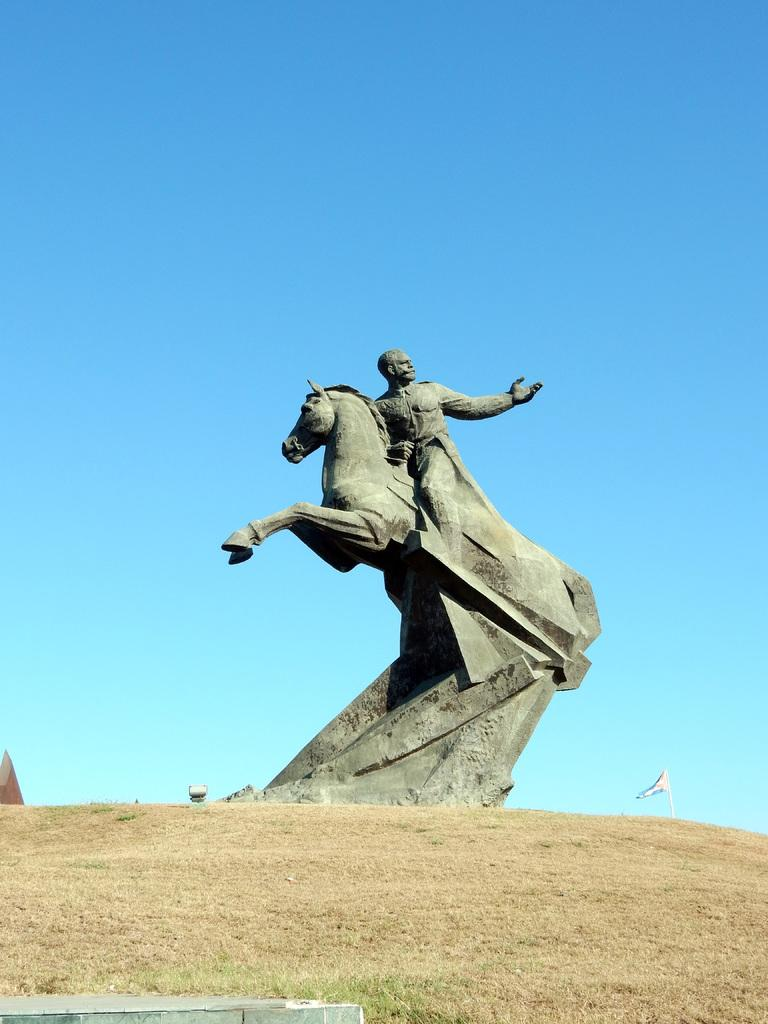What is the main subject of the image? There is a sculpture in the image. What type of vegetation can be seen in the image? There is dry grass in the image. What other object is present in the image? There is a flag in the image. What can be seen in the background of the image? The sky is visible in the background of the image. What type of silk material is draped over the sculpture in the image? There is no silk material present in the image; the sculpture is not draped with any fabric. 